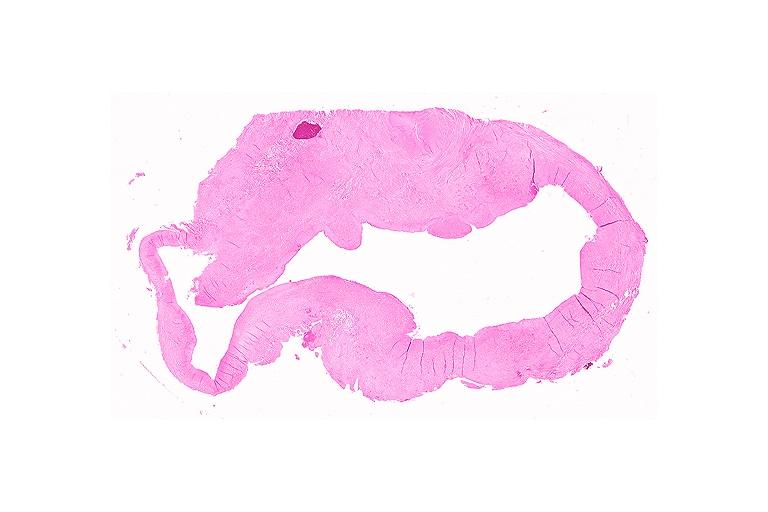does this image show cyst?
Answer the question using a single word or phrase. Yes 